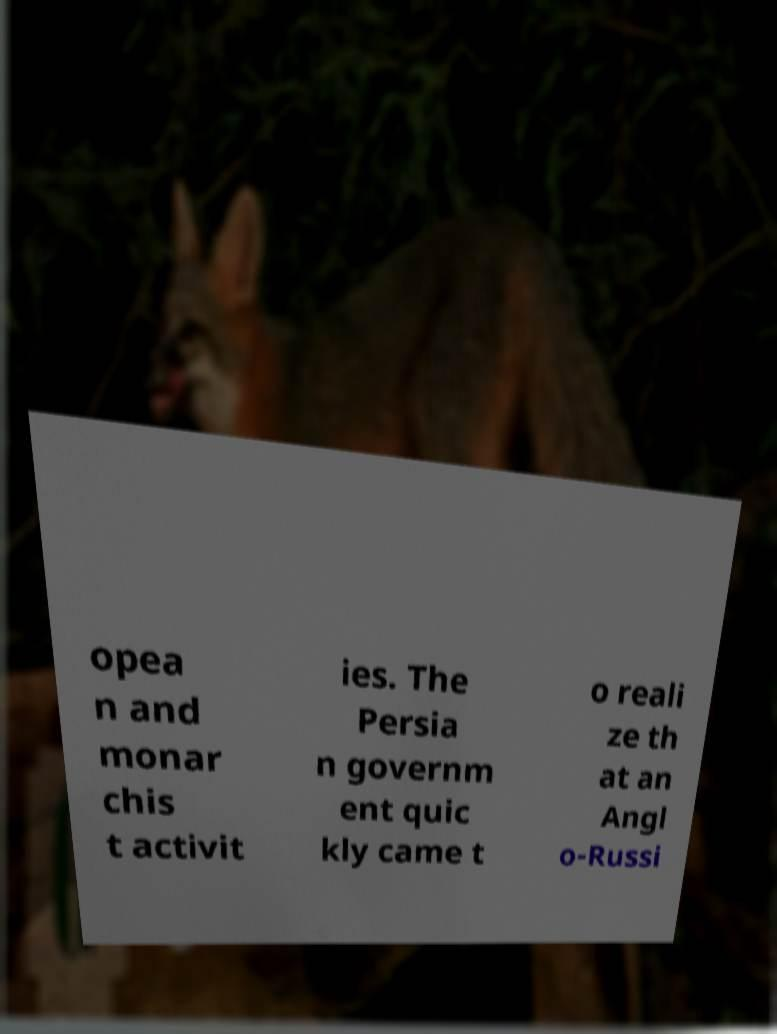Can you read and provide the text displayed in the image?This photo seems to have some interesting text. Can you extract and type it out for me? opea n and monar chis t activit ies. The Persia n governm ent quic kly came t o reali ze th at an Angl o-Russi 